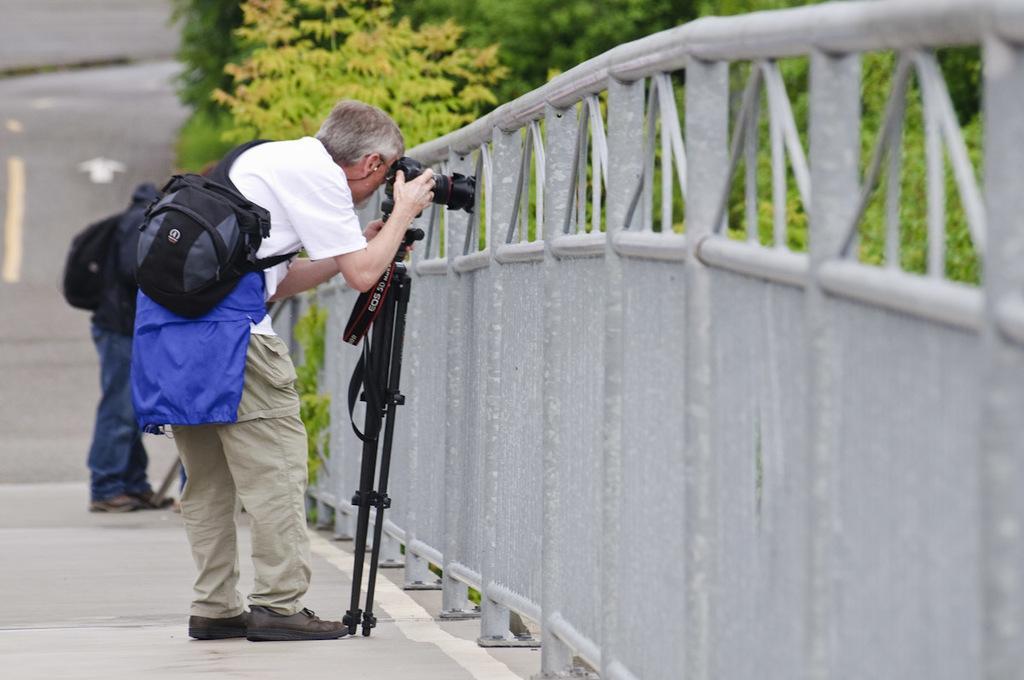Can you describe this image briefly? In this image I can see a person standing holding a camera. The person is wearing white shirt, cream pant and black color bag. Background I can see the other person standing and trees in green color. 